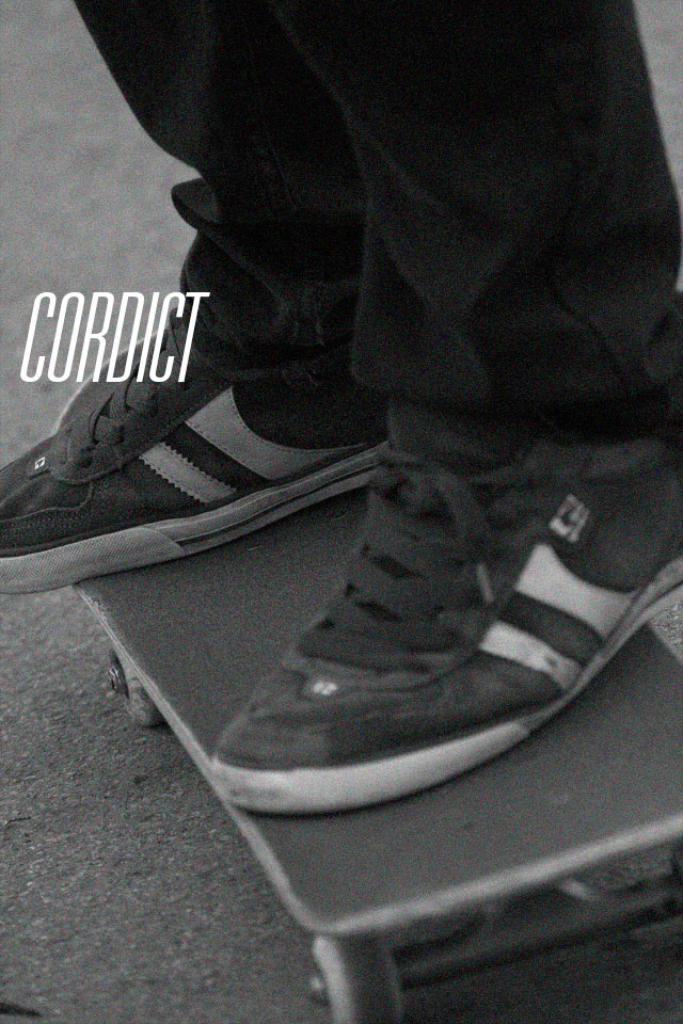In one or two sentences, can you explain what this image depicts? In the image we can see there is a person standing on the roller skate board and the image is in black and white colour. On the image its written "CORDICT". 